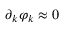<formula> <loc_0><loc_0><loc_500><loc_500>\partial _ { k } \varphi _ { k } \approx 0</formula> 